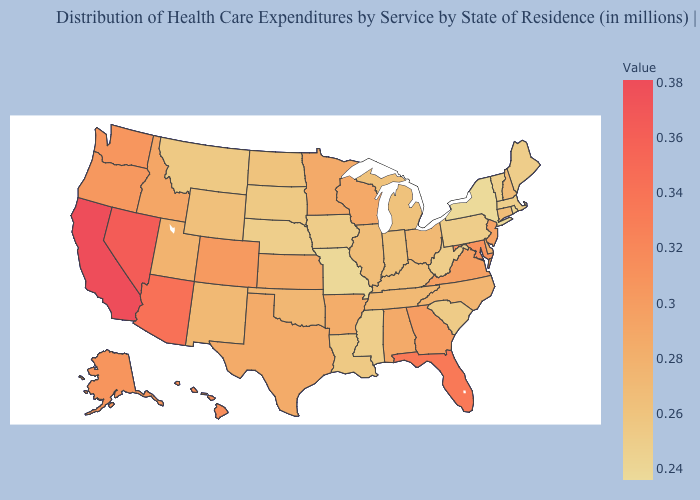Which states have the highest value in the USA?
Short answer required. California. Does New Mexico have a higher value than New Jersey?
Short answer required. No. Does Montana have the lowest value in the USA?
Quick response, please. No. Among the states that border Tennessee , which have the highest value?
Answer briefly. Georgia. Which states hav the highest value in the West?
Short answer required. California. Which states have the lowest value in the South?
Answer briefly. Mississippi. Does Texas have a lower value than Alaska?
Be succinct. Yes. Does Alabama have a lower value than Washington?
Give a very brief answer. Yes. 